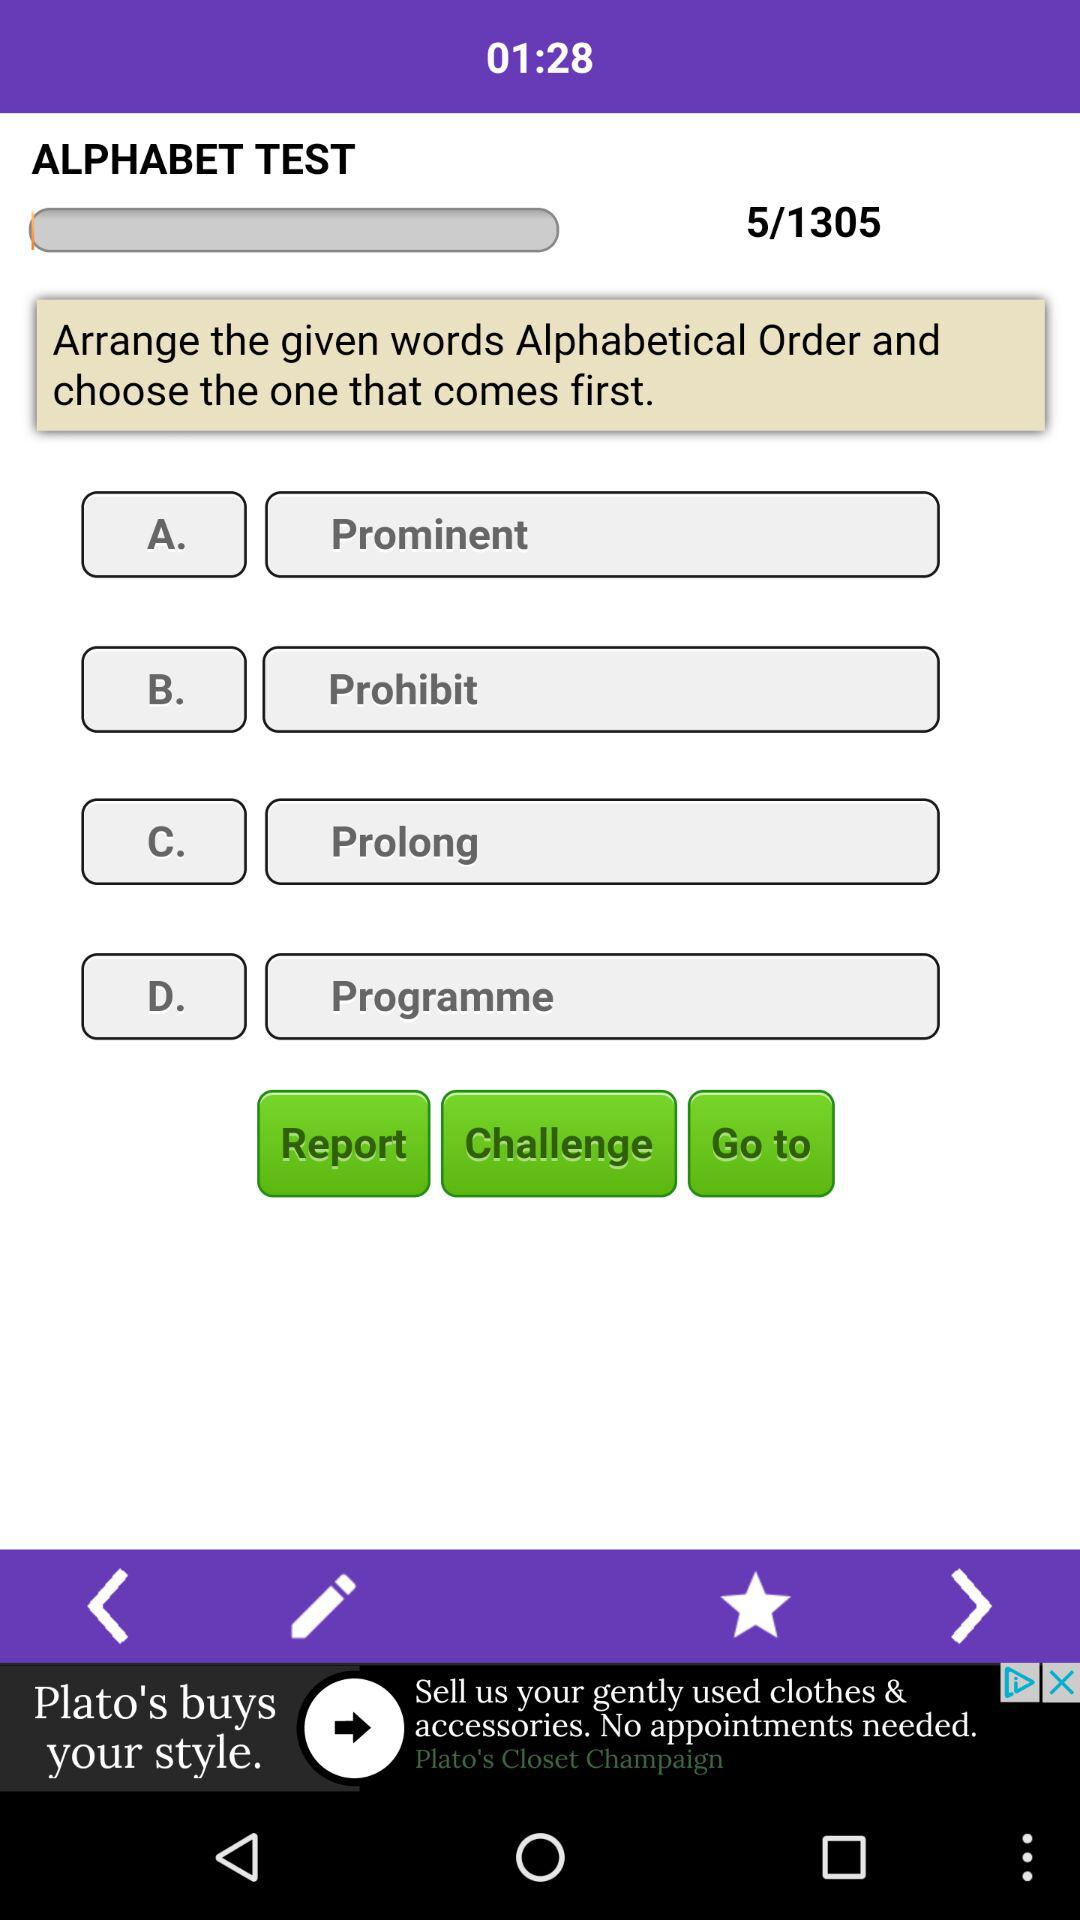How many questions are there? There are 1305 questions. 